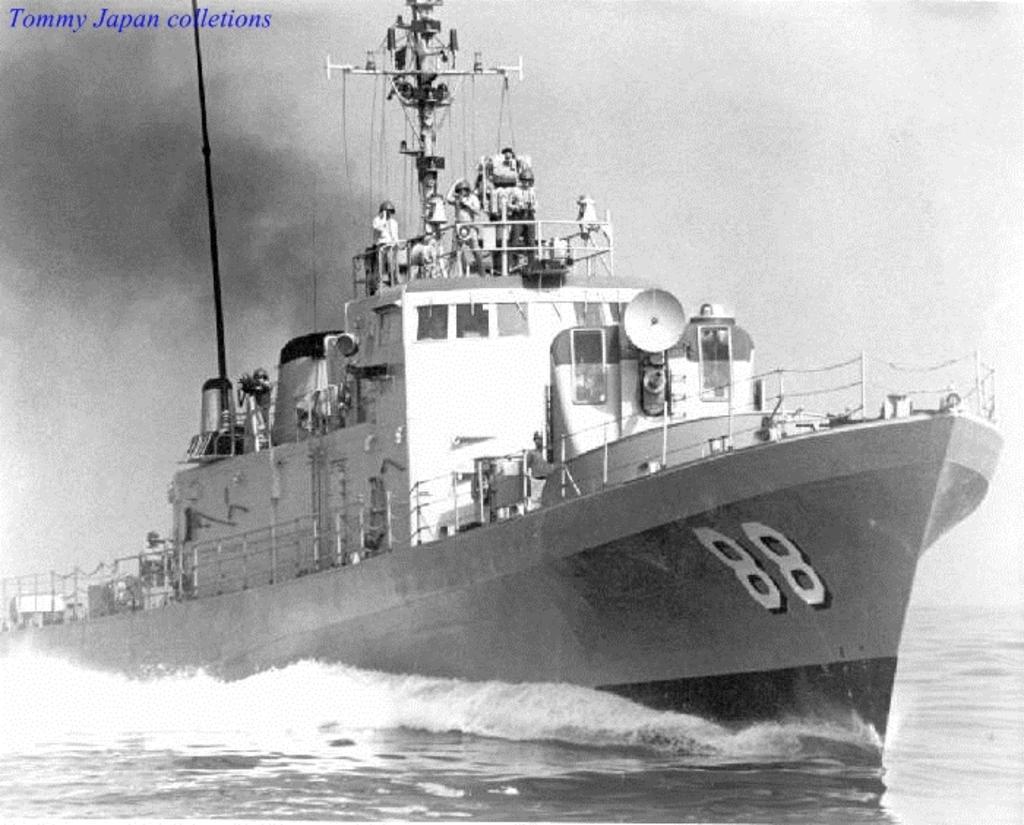How would you summarize this image in a sentence or two? In this picture we can see a few people on a boat. Waves are visible in water. A watermark is visible on the left side. 